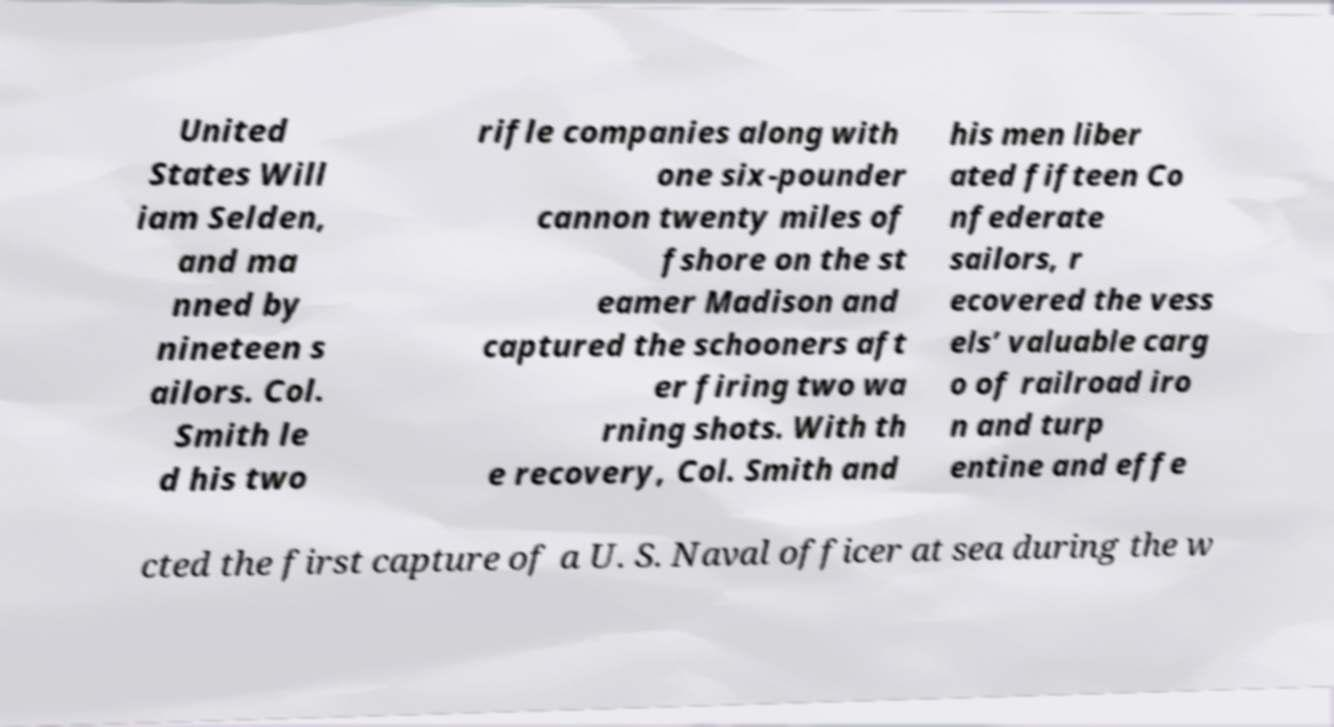Could you extract and type out the text from this image? United States Will iam Selden, and ma nned by nineteen s ailors. Col. Smith le d his two rifle companies along with one six-pounder cannon twenty miles of fshore on the st eamer Madison and captured the schooners aft er firing two wa rning shots. With th e recovery, Col. Smith and his men liber ated fifteen Co nfederate sailors, r ecovered the vess els’ valuable carg o of railroad iro n and turp entine and effe cted the first capture of a U. S. Naval officer at sea during the w 